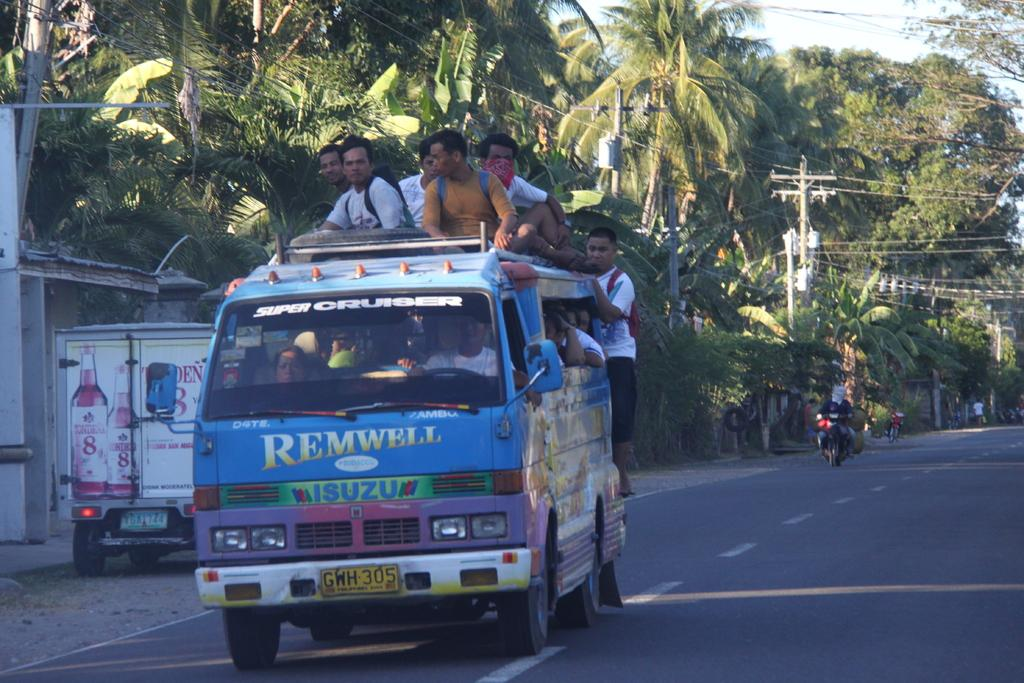What is happening on the road in the image? There are vehicles on a road in the image. Can you describe the people in the image? There are people sitting on one of the vehicles. What can be seen in the background of the image? There are trees, electrical poles, and wires in the background of the image. What type of bait is being used by the dad in the image? There is no dad or bait present in the image. How many clocks can be seen in the image? There are no clocks visible in the image. 